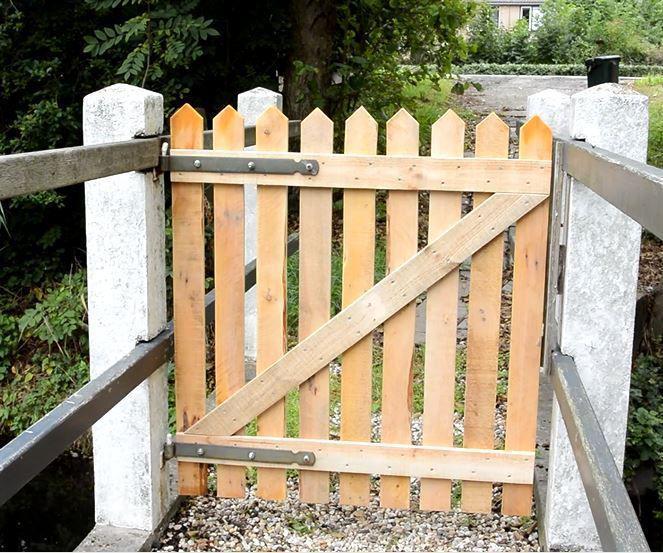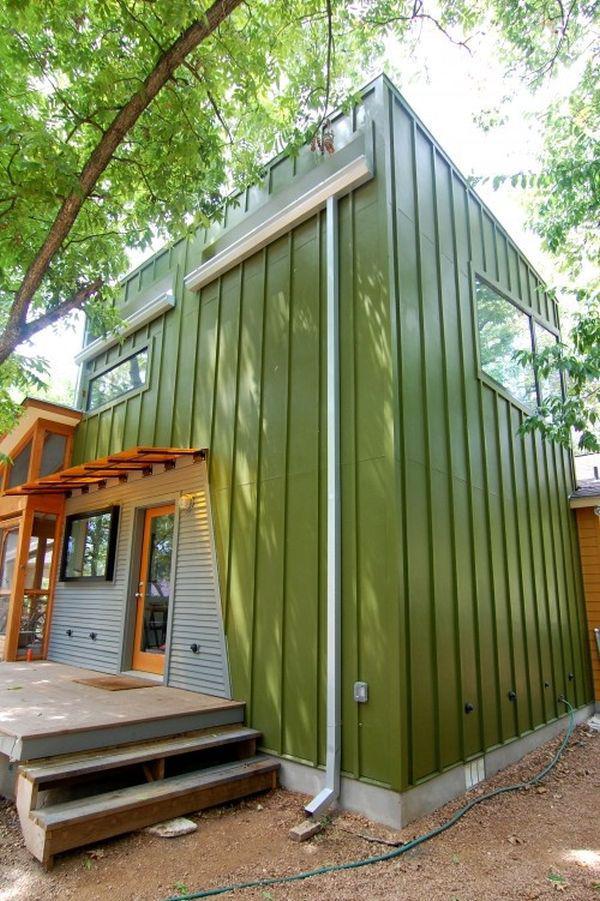The first image is the image on the left, the second image is the image on the right. For the images displayed, is the sentence "The left and right image contains the same number of staircases." factually correct? Answer yes or no. No. 